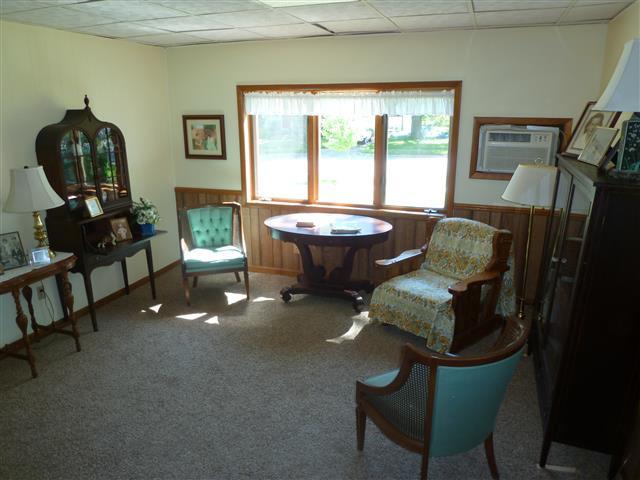Is the light on?
Short answer required. No. Is this a dining room?
Quick response, please. No. What time of day?
Quick response, please. Afternoon. Is there natural light?
Write a very short answer. Yes. 